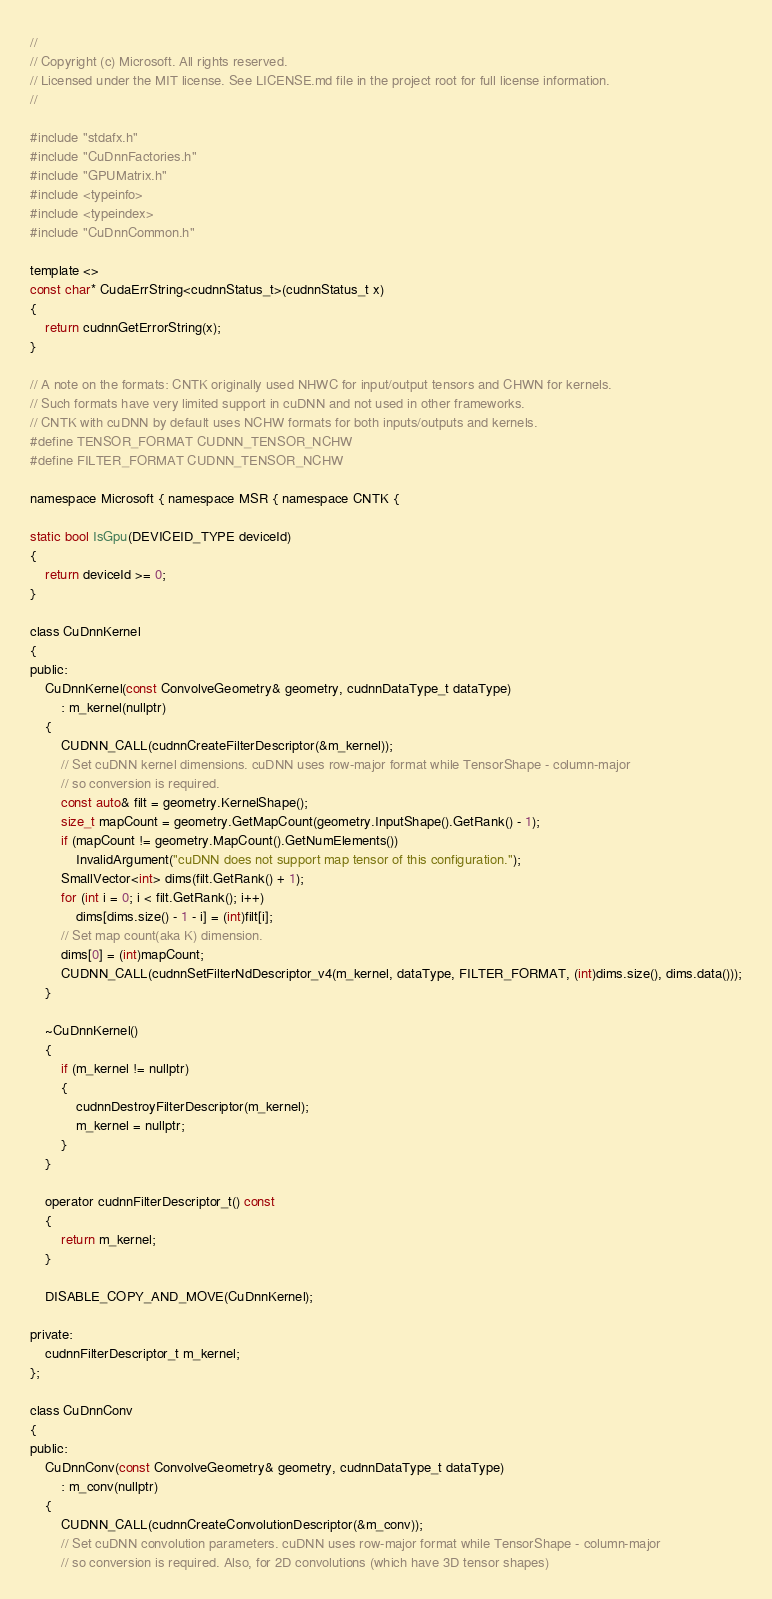<code> <loc_0><loc_0><loc_500><loc_500><_Cuda_>//
// Copyright (c) Microsoft. All rights reserved.
// Licensed under the MIT license. See LICENSE.md file in the project root for full license information.
//

#include "stdafx.h"
#include "CuDnnFactories.h"
#include "GPUMatrix.h"
#include <typeinfo>
#include <typeindex>
#include "CuDnnCommon.h"

template <>
const char* CudaErrString<cudnnStatus_t>(cudnnStatus_t x)
{
    return cudnnGetErrorString(x);
}

// A note on the formats: CNTK originally used NHWC for input/output tensors and CHWN for kernels.
// Such formats have very limited support in cuDNN and not used in other frameworks.
// CNTK with cuDNN by default uses NCHW formats for both inputs/outputs and kernels.
#define TENSOR_FORMAT CUDNN_TENSOR_NCHW
#define FILTER_FORMAT CUDNN_TENSOR_NCHW

namespace Microsoft { namespace MSR { namespace CNTK {

static bool IsGpu(DEVICEID_TYPE deviceId)
{
    return deviceId >= 0;
}

class CuDnnKernel
{
public:
    CuDnnKernel(const ConvolveGeometry& geometry, cudnnDataType_t dataType)
        : m_kernel(nullptr)
    {
        CUDNN_CALL(cudnnCreateFilterDescriptor(&m_kernel));
        // Set cuDNN kernel dimensions. cuDNN uses row-major format while TensorShape - column-major
        // so conversion is required.
        const auto& filt = geometry.KernelShape();
        size_t mapCount = geometry.GetMapCount(geometry.InputShape().GetRank() - 1);
        if (mapCount != geometry.MapCount().GetNumElements())
            InvalidArgument("cuDNN does not support map tensor of this configuration.");
        SmallVector<int> dims(filt.GetRank() + 1);
        for (int i = 0; i < filt.GetRank(); i++)
            dims[dims.size() - 1 - i] = (int)filt[i];
        // Set map count(aka K) dimension.
        dims[0] = (int)mapCount;
        CUDNN_CALL(cudnnSetFilterNdDescriptor_v4(m_kernel, dataType, FILTER_FORMAT, (int)dims.size(), dims.data()));
    }

    ~CuDnnKernel()
    {
        if (m_kernel != nullptr)
        {
            cudnnDestroyFilterDescriptor(m_kernel);
            m_kernel = nullptr;
        }
    }

    operator cudnnFilterDescriptor_t() const
    {
        return m_kernel;
    }

    DISABLE_COPY_AND_MOVE(CuDnnKernel);

private:
    cudnnFilterDescriptor_t m_kernel;
};

class CuDnnConv
{
public:
    CuDnnConv(const ConvolveGeometry& geometry, cudnnDataType_t dataType)
        : m_conv(nullptr)
    {
        CUDNN_CALL(cudnnCreateConvolutionDescriptor(&m_conv));
        // Set cuDNN convolution parameters. cuDNN uses row-major format while TensorShape - column-major
        // so conversion is required. Also, for 2D convolutions (which have 3D tensor shapes)</code> 